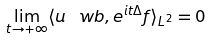Convert formula to latex. <formula><loc_0><loc_0><loc_500><loc_500>\lim _ { t \to + \infty } \langle u _ { \ } w b , e ^ { i t \Delta } f \rangle _ { L ^ { 2 } } = 0</formula> 